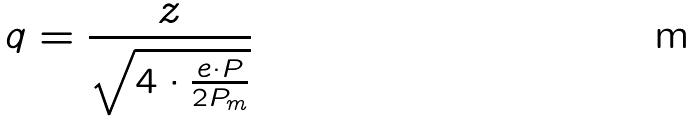Convert formula to latex. <formula><loc_0><loc_0><loc_500><loc_500>q = \frac { z } { \sqrt { 4 \cdot \frac { e \cdot P } { 2 P _ { m } } } }</formula> 